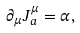<formula> <loc_0><loc_0><loc_500><loc_500>\partial _ { \mu } J _ { a } ^ { \mu } = \alpha ,</formula> 